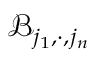Convert formula to latex. <formula><loc_0><loc_0><loc_500><loc_500>\mathcal { B } _ { j _ { 1 } , \cdot , j _ { n } }</formula> 